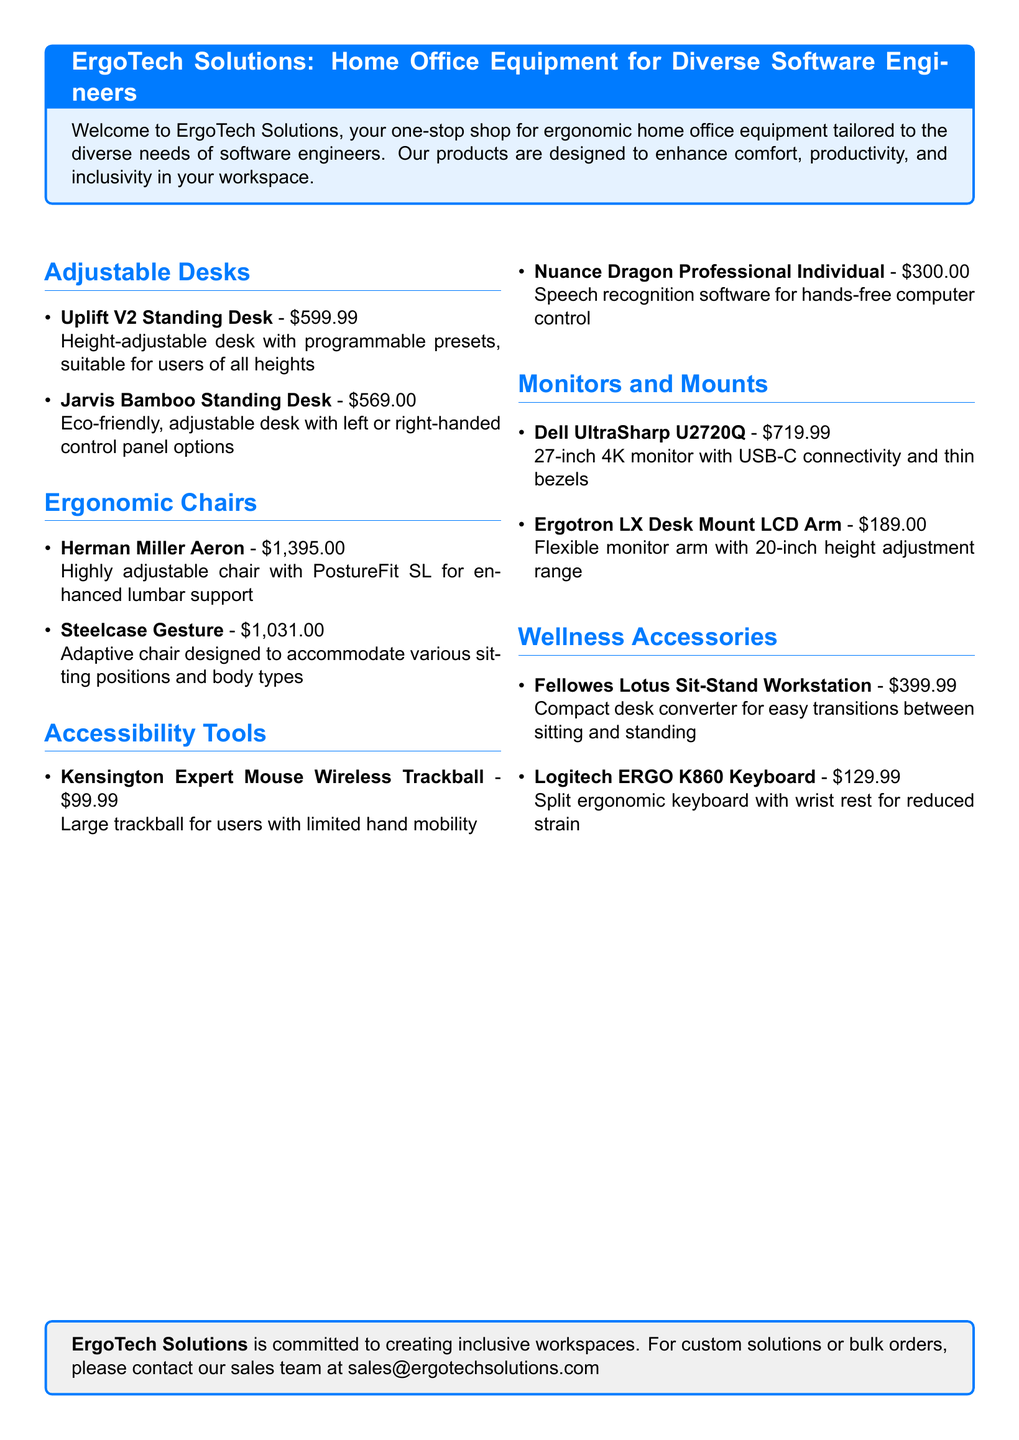What is the price of the Uplift V2 Standing Desk? This information can be found in the Adjustable Desks section where it states the price of the Uplift V2 Standing Desk is $599.99.
Answer: $599.99 How many ergonomic chairs are listed in the catalog? The catalog includes two ergonomic chairs: the Herman Miller Aeron and the Steelcase Gesture.
Answer: 2 What is the main feature of the Kensington Expert Mouse Wireless Trackball? The main feature mentioned in the Accessibility Tools section is that it is designed for users with limited hand mobility.
Answer: Limited hand mobility What is the price of the Logitech ERGO K860 Keyboard? The price for the Logitech ERGO K860 Keyboard is specified in the Wellness Accessories section as $129.99.
Answer: $129.99 Which adjustable desk is eco-friendly? The Jarvis Bamboo Standing Desk is mentioned as eco-friendly in the Adjustable Desks section.
Answer: Jarvis Bamboo Standing Desk How much does the Dell UltraSharp U2720Q cost? The cost of the Dell UltraSharp U2720Q can be found in the Monitors and Mounts section, and it is $719.99.
Answer: $719.99 What tool is designed for hands-free computer control? In the Accessibility Tools section, the Nuance Dragon Professional Individual is identified as the tool designed for hands-free computer control.
Answer: Nuance Dragon Professional Individual What is the color scheme of the catalog's title box? The color scheme used for the title box is light blue, as indicated by the color definitions in the document.
Answer: Light blue What type of accessories does ErgoTech Solutions promote? The document focuses on ergonomic home office equipment and accessories tailored for software engineers.
Answer: Ergonomic home office equipment 